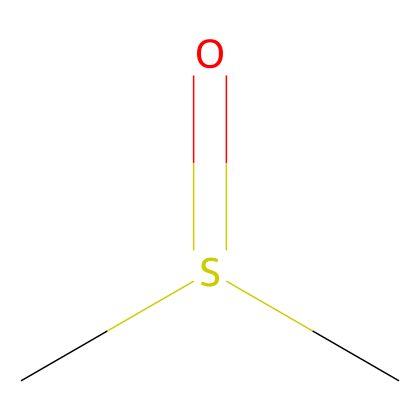What is the total number of atoms in dimethyl sulfoxide? The SMILES representation shows two carbon atoms (C), one sulfur atom (S), and one oxygen atom (O). Adding these together gives a total of four atoms.
Answer: 4 How many carbon atoms are present in DMSO? The chemical structure indicates two carbon atoms (C) are present, as represented by the two 'C' in the SMILES.
Answer: 2 What functional group is present in DMSO? The presence of the sulfur atom bonded to an oxygen atom (S(=O)) indicates that DMSO contains a sulfoxide functional group, which is characteristic of this compound.
Answer: sulfoxide What is the oxidation state of sulfur in DMSO? Sulfur is bonded to an oxygen atom with a double bond (S=O) and to two carbon atoms. This indicates that sulfur is in an oxidation state of +4, considering it can have a maximum oxidation state of +6.
Answer: +4 What type of intermolecular forces are present in dimethyl sulfoxide? DMSO has polar characteristics due to the electronegativity difference between sulfur and oxygen, leading to dipole-dipole interactions and possibly hydrogen bonding with water or other polar solvents, reflecting its polar solvent nature.
Answer: dipole-dipole How many hydrogen atoms are there in DMSO? Since each carbon atom in DMSO can bond with three hydrogen atoms based on carbon’s tetravalency, and given that there are two carbons, there are a total of six hydrogen atoms.
Answer: 6 What is the main application of DMSO in cleaning products? DMSO is primarily used as a solvent in many cleaning products due to its ability to dissolve both polar and nonpolar compounds, making it effective for various cleaning applications.
Answer: solvent 